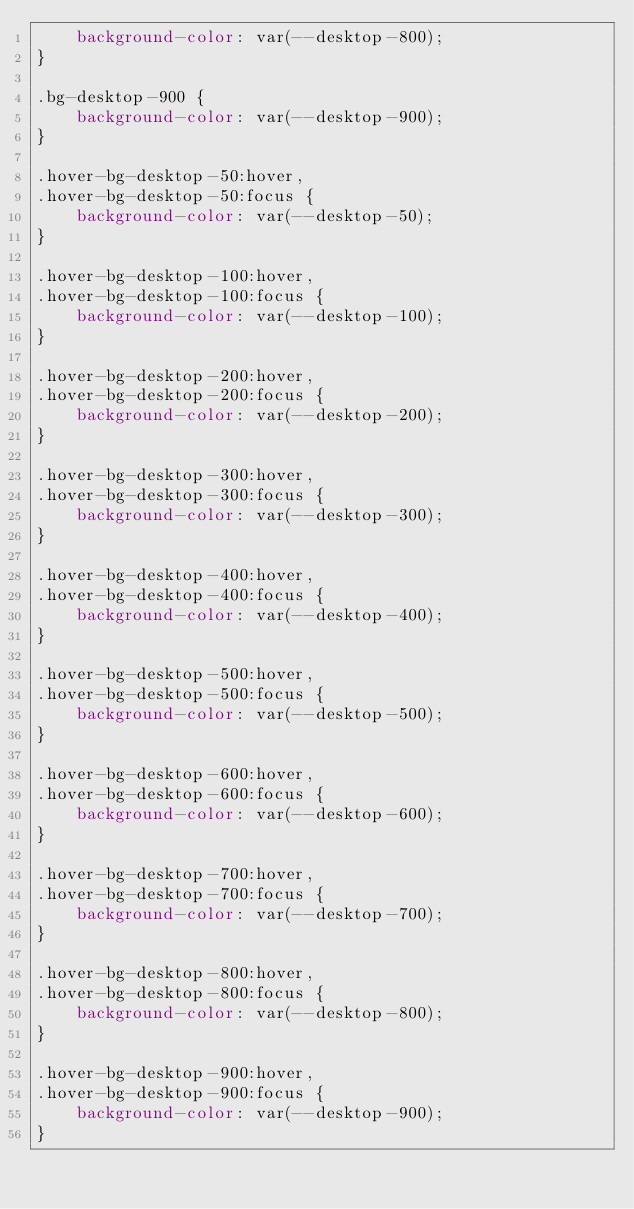Convert code to text. <code><loc_0><loc_0><loc_500><loc_500><_CSS_>    background-color: var(--desktop-800);
}

.bg-desktop-900 {
    background-color: var(--desktop-900);
}

.hover-bg-desktop-50:hover,
.hover-bg-desktop-50:focus {
    background-color: var(--desktop-50);
}

.hover-bg-desktop-100:hover,
.hover-bg-desktop-100:focus {
    background-color: var(--desktop-100);
}

.hover-bg-desktop-200:hover,
.hover-bg-desktop-200:focus {
    background-color: var(--desktop-200);
}

.hover-bg-desktop-300:hover,
.hover-bg-desktop-300:focus {
    background-color: var(--desktop-300);
}

.hover-bg-desktop-400:hover,
.hover-bg-desktop-400:focus {
    background-color: var(--desktop-400);
}

.hover-bg-desktop-500:hover,
.hover-bg-desktop-500:focus {
    background-color: var(--desktop-500);
}

.hover-bg-desktop-600:hover,
.hover-bg-desktop-600:focus {
    background-color: var(--desktop-600);
}

.hover-bg-desktop-700:hover,
.hover-bg-desktop-700:focus {
    background-color: var(--desktop-700);
}

.hover-bg-desktop-800:hover,
.hover-bg-desktop-800:focus {
    background-color: var(--desktop-800);
}

.hover-bg-desktop-900:hover,
.hover-bg-desktop-900:focus {
    background-color: var(--desktop-900);
}
</code> 